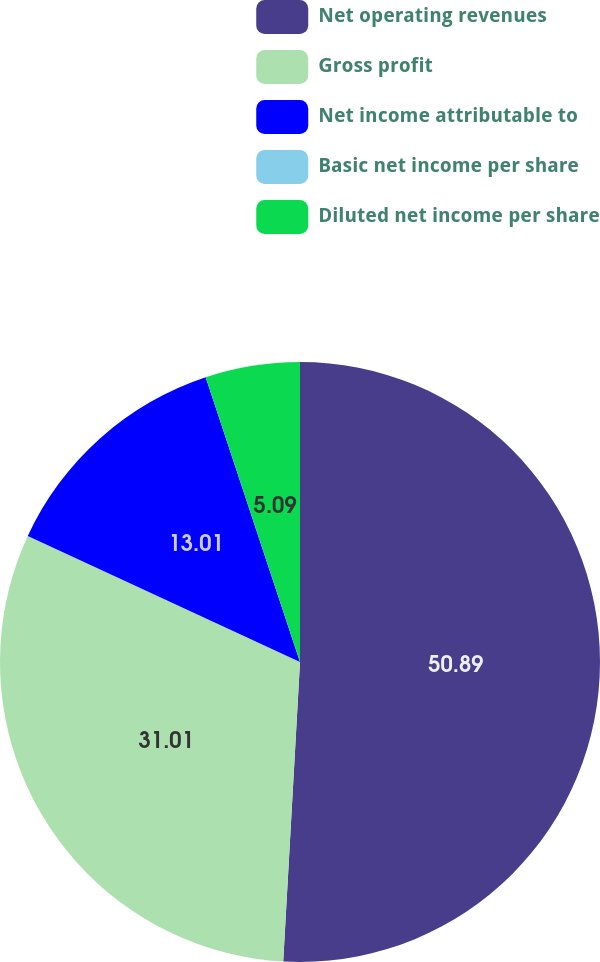<chart> <loc_0><loc_0><loc_500><loc_500><pie_chart><fcel>Net operating revenues<fcel>Gross profit<fcel>Net income attributable to<fcel>Basic net income per share<fcel>Diluted net income per share<nl><fcel>50.89%<fcel>31.01%<fcel>13.01%<fcel>0.0%<fcel>5.09%<nl></chart> 